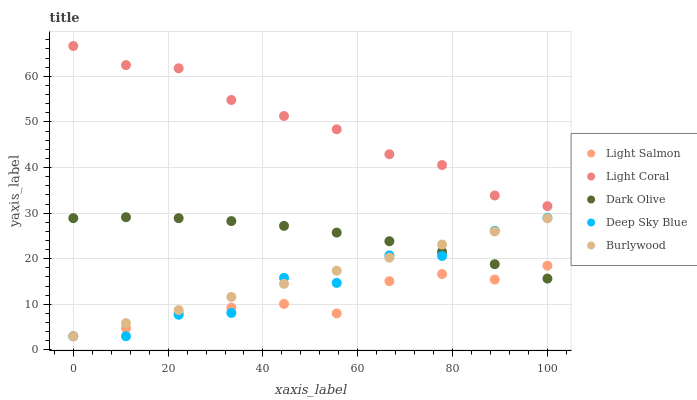Does Light Salmon have the minimum area under the curve?
Answer yes or no. Yes. Does Light Coral have the maximum area under the curve?
Answer yes or no. Yes. Does Burlywood have the minimum area under the curve?
Answer yes or no. No. Does Burlywood have the maximum area under the curve?
Answer yes or no. No. Is Burlywood the smoothest?
Answer yes or no. Yes. Is Deep Sky Blue the roughest?
Answer yes or no. Yes. Is Light Salmon the smoothest?
Answer yes or no. No. Is Light Salmon the roughest?
Answer yes or no. No. Does Burlywood have the lowest value?
Answer yes or no. Yes. Does Dark Olive have the lowest value?
Answer yes or no. No. Does Light Coral have the highest value?
Answer yes or no. Yes. Does Burlywood have the highest value?
Answer yes or no. No. Is Deep Sky Blue less than Light Coral?
Answer yes or no. Yes. Is Light Coral greater than Burlywood?
Answer yes or no. Yes. Does Deep Sky Blue intersect Dark Olive?
Answer yes or no. Yes. Is Deep Sky Blue less than Dark Olive?
Answer yes or no. No. Is Deep Sky Blue greater than Dark Olive?
Answer yes or no. No. Does Deep Sky Blue intersect Light Coral?
Answer yes or no. No. 